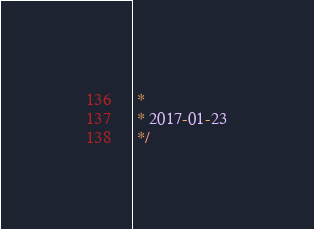Convert code to text. <code><loc_0><loc_0><loc_500><loc_500><_JavaScript_> *
 * 2017-01-23
 */

</code> 